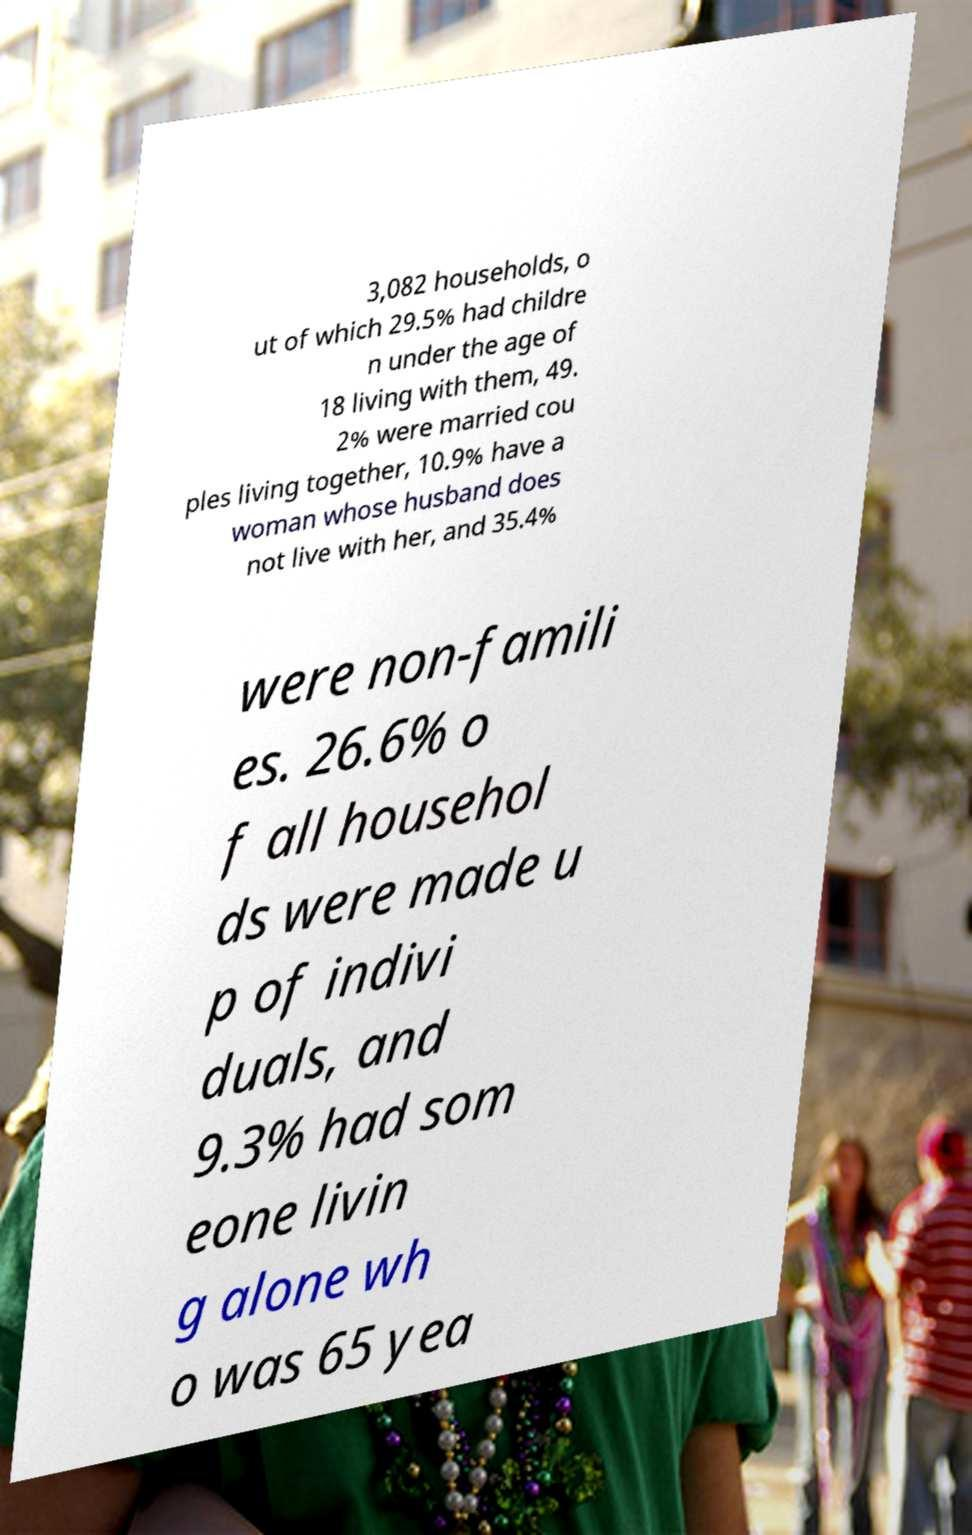For documentation purposes, I need the text within this image transcribed. Could you provide that? 3,082 households, o ut of which 29.5% had childre n under the age of 18 living with them, 49. 2% were married cou ples living together, 10.9% have a woman whose husband does not live with her, and 35.4% were non-famili es. 26.6% o f all househol ds were made u p of indivi duals, and 9.3% had som eone livin g alone wh o was 65 yea 